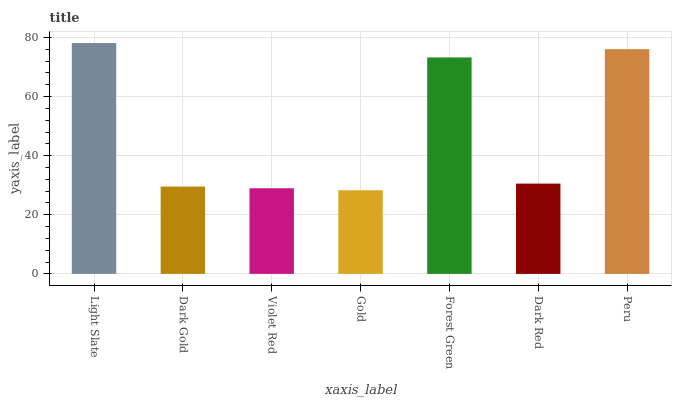Is Gold the minimum?
Answer yes or no. Yes. Is Light Slate the maximum?
Answer yes or no. Yes. Is Dark Gold the minimum?
Answer yes or no. No. Is Dark Gold the maximum?
Answer yes or no. No. Is Light Slate greater than Dark Gold?
Answer yes or no. Yes. Is Dark Gold less than Light Slate?
Answer yes or no. Yes. Is Dark Gold greater than Light Slate?
Answer yes or no. No. Is Light Slate less than Dark Gold?
Answer yes or no. No. Is Dark Red the high median?
Answer yes or no. Yes. Is Dark Red the low median?
Answer yes or no. Yes. Is Forest Green the high median?
Answer yes or no. No. Is Dark Gold the low median?
Answer yes or no. No. 